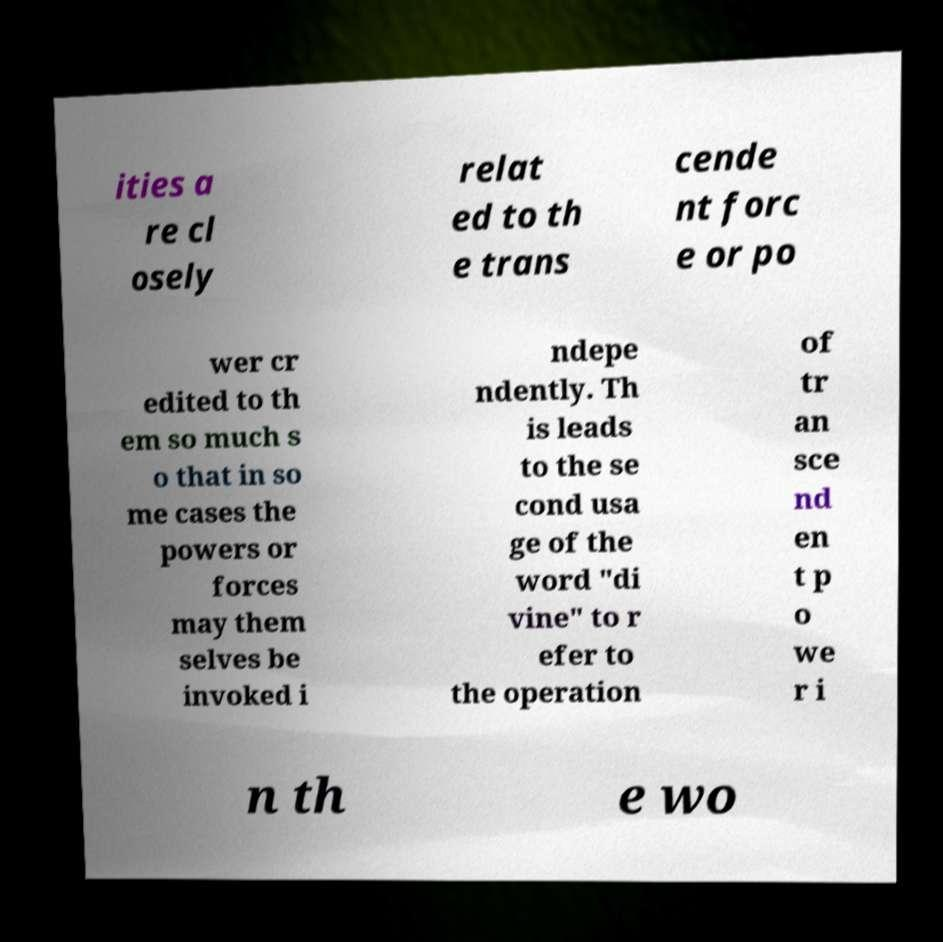What messages or text are displayed in this image? I need them in a readable, typed format. ities a re cl osely relat ed to th e trans cende nt forc e or po wer cr edited to th em so much s o that in so me cases the powers or forces may them selves be invoked i ndepe ndently. Th is leads to the se cond usa ge of the word "di vine" to r efer to the operation of tr an sce nd en t p o we r i n th e wo 